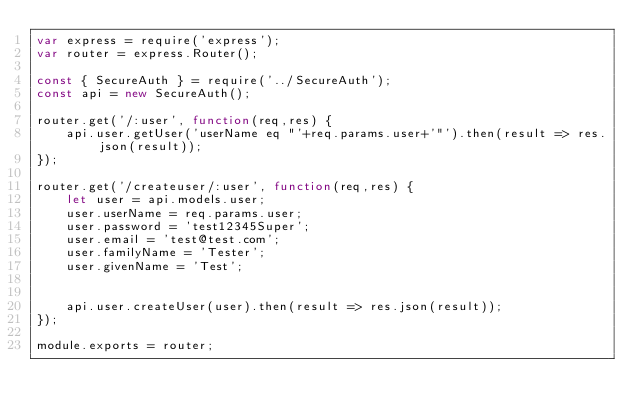Convert code to text. <code><loc_0><loc_0><loc_500><loc_500><_JavaScript_>var express = require('express');
var router = express.Router();

const { SecureAuth } = require('../SecureAuth');
const api = new SecureAuth();

router.get('/:user', function(req,res) {
    api.user.getUser('userName eq "'+req.params.user+'"').then(result => res.json(result));
});

router.get('/createuser/:user', function(req,res) {
    let user = api.models.user;
    user.userName = req.params.user;
    user.password = 'test12345Super';
    user.email = 'test@test.com';
    user.familyName = 'Tester';
    user.givenName = 'Test';
    

    api.user.createUser(user).then(result => res.json(result));
});

module.exports = router;</code> 